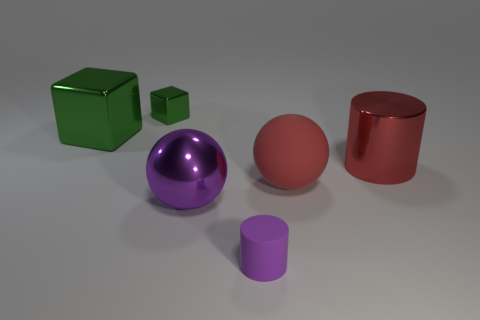Add 1 tiny cyan shiny balls. How many objects exist? 7 Subtract all red cylinders. How many cylinders are left? 1 Subtract 2 cylinders. How many cylinders are left? 0 Subtract all brown blocks. Subtract all red balls. How many blocks are left? 2 Subtract all big yellow shiny cubes. Subtract all red metal things. How many objects are left? 5 Add 6 big balls. How many big balls are left? 8 Add 1 big yellow metal cubes. How many big yellow metal cubes exist? 1 Subtract 2 green cubes. How many objects are left? 4 